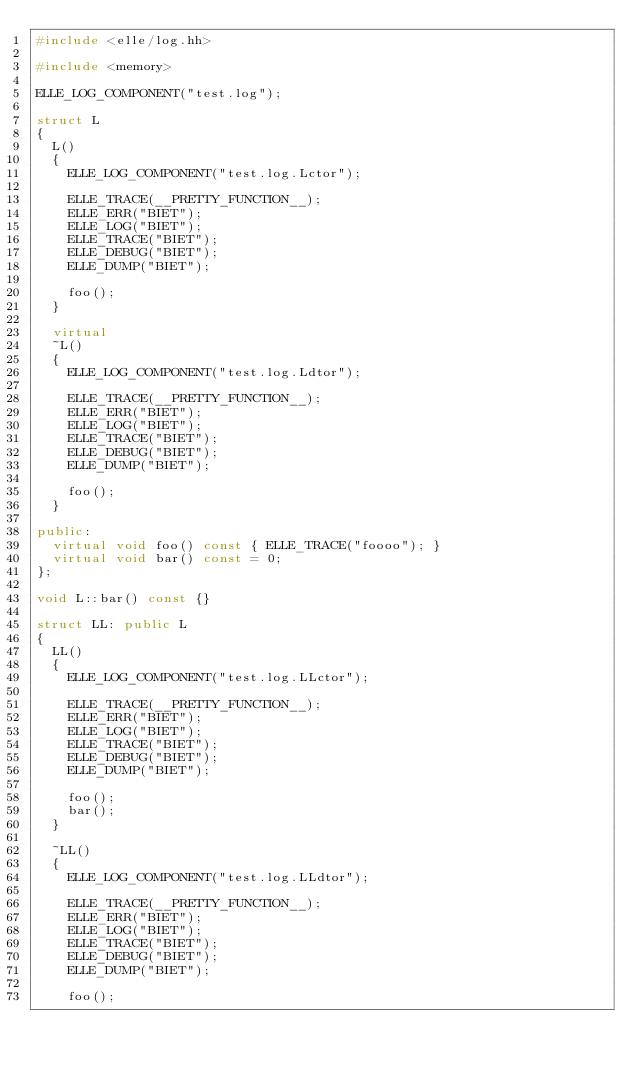<code> <loc_0><loc_0><loc_500><loc_500><_C++_>#include <elle/log.hh>

#include <memory>

ELLE_LOG_COMPONENT("test.log");

struct L
{
  L()
  {
    ELLE_LOG_COMPONENT("test.log.Lctor");

    ELLE_TRACE(__PRETTY_FUNCTION__);
    ELLE_ERR("BIET");
    ELLE_LOG("BIET");
    ELLE_TRACE("BIET");
    ELLE_DEBUG("BIET");
    ELLE_DUMP("BIET");

    foo();
  }

  virtual
  ~L()
  {
    ELLE_LOG_COMPONENT("test.log.Ldtor");

    ELLE_TRACE(__PRETTY_FUNCTION__);
    ELLE_ERR("BIET");
    ELLE_LOG("BIET");
    ELLE_TRACE("BIET");
    ELLE_DEBUG("BIET");
    ELLE_DUMP("BIET");

    foo();
  }

public:
  virtual void foo() const { ELLE_TRACE("foooo"); }
  virtual void bar() const = 0;
};

void L::bar() const {}

struct LL: public L
{
  LL()
  {
    ELLE_LOG_COMPONENT("test.log.LLctor");

    ELLE_TRACE(__PRETTY_FUNCTION__);
    ELLE_ERR("BIET");
    ELLE_LOG("BIET");
    ELLE_TRACE("BIET");
    ELLE_DEBUG("BIET");
    ELLE_DUMP("BIET");

    foo();
    bar();
  }

  ~LL()
  {
    ELLE_LOG_COMPONENT("test.log.LLdtor");

    ELLE_TRACE(__PRETTY_FUNCTION__);
    ELLE_ERR("BIET");
    ELLE_LOG("BIET");
    ELLE_TRACE("BIET");
    ELLE_DEBUG("BIET");
    ELLE_DUMP("BIET");

    foo();</code> 